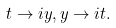Convert formula to latex. <formula><loc_0><loc_0><loc_500><loc_500>t \rightarrow i y , y \rightarrow i t .</formula> 